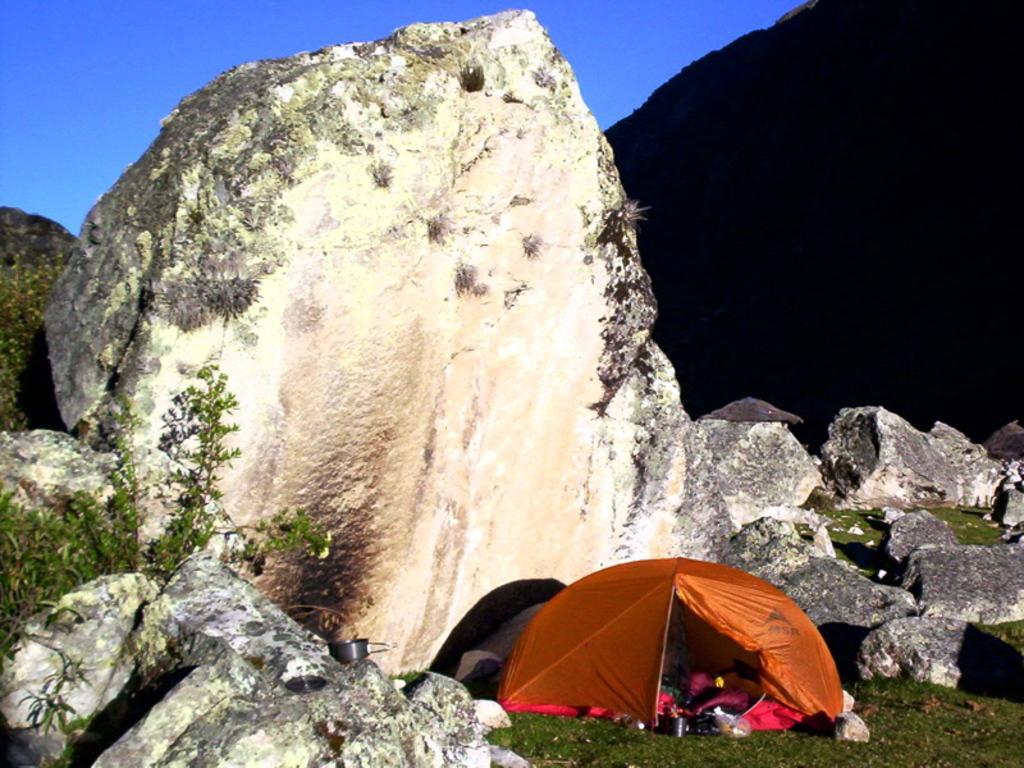Can you describe this image briefly? There is an orange color tint on the grass on the ground, in which, there are some objects, near rocks. In the background, there is hill and there is blue sky. 